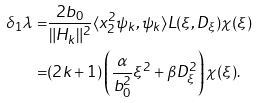Convert formula to latex. <formula><loc_0><loc_0><loc_500><loc_500>\delta _ { 1 } \lambda = & \frac { 2 b _ { 0 } } { \| H _ { k } \| ^ { 2 } } \langle x _ { 2 } ^ { 2 } \psi _ { k } , \psi _ { k } \rangle L ( \xi , D _ { \xi } ) \chi ( \xi ) \\ = & ( 2 k + 1 ) \left ( \frac { \alpha } { b ^ { 2 } _ { 0 } } \xi ^ { 2 } + \beta D ^ { 2 } _ { \xi } \right ) \chi ( \xi ) .</formula> 